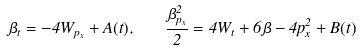<formula> <loc_0><loc_0><loc_500><loc_500>\beta _ { t } = - 4 W _ { p _ { x } } + A ( t ) , \quad \frac { \beta _ { p _ { x } } ^ { 2 } } 2 = 4 W _ { t } + 6 \beta - 4 p _ { x } ^ { 2 } + B ( t )</formula> 